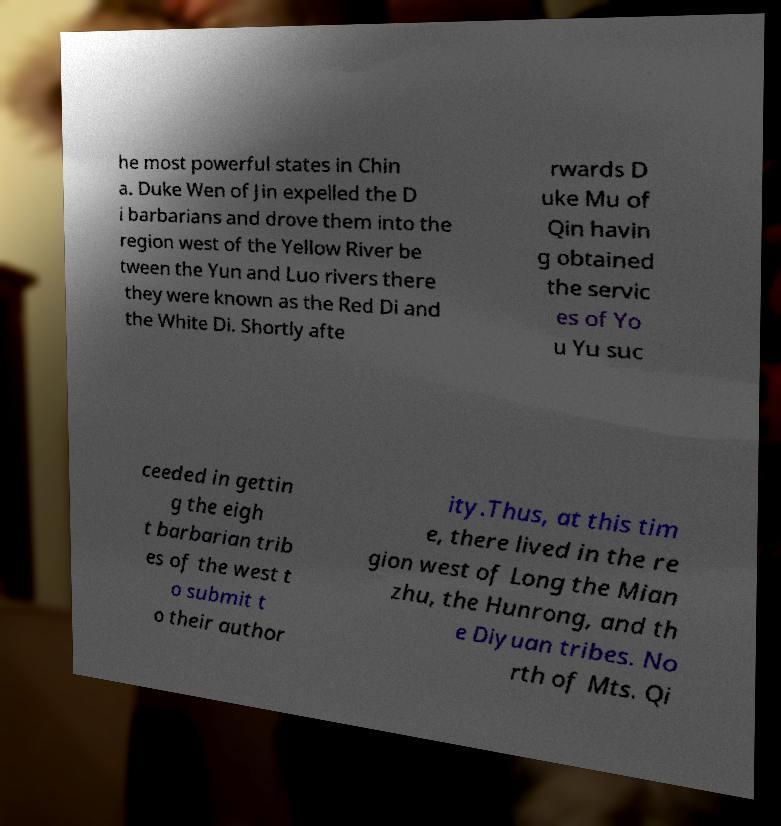For documentation purposes, I need the text within this image transcribed. Could you provide that? he most powerful states in Chin a. Duke Wen of Jin expelled the D i barbarians and drove them into the region west of the Yellow River be tween the Yun and Luo rivers there they were known as the Red Di and the White Di. Shortly afte rwards D uke Mu of Qin havin g obtained the servic es of Yo u Yu suc ceeded in gettin g the eigh t barbarian trib es of the west t o submit t o their author ity.Thus, at this tim e, there lived in the re gion west of Long the Mian zhu, the Hunrong, and th e Diyuan tribes. No rth of Mts. Qi 